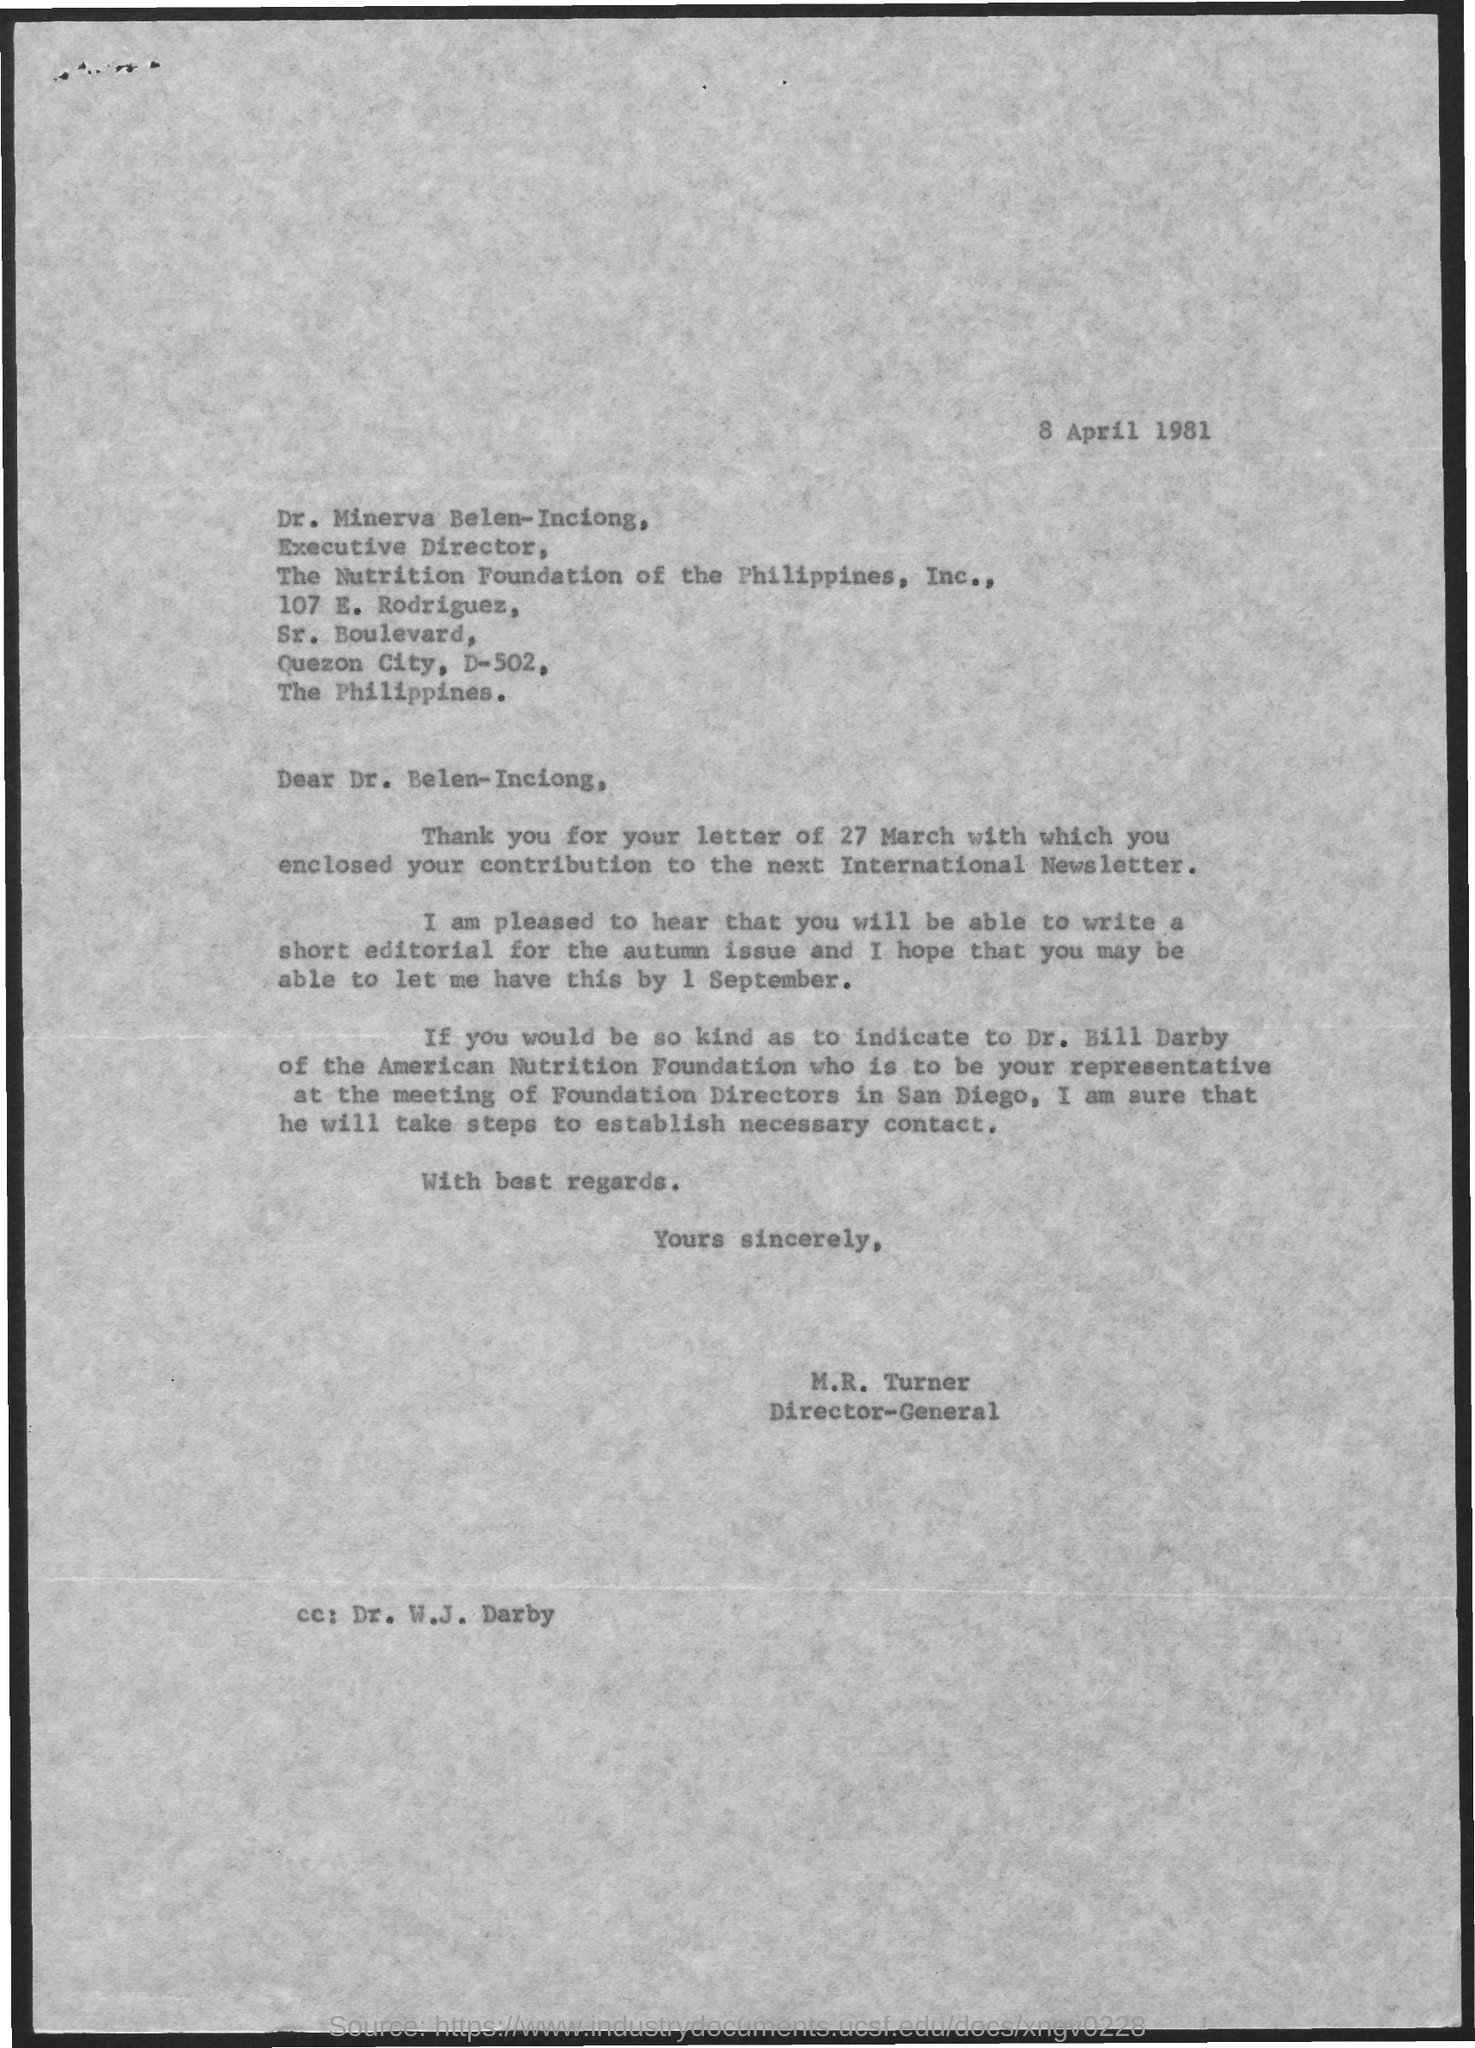Give some essential details in this illustration. Dr. Minerva Belen-Inciong holds the designation of Executive Director. 